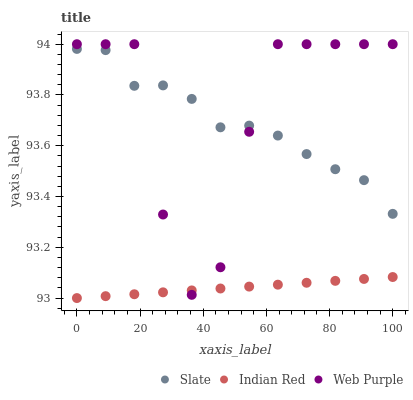Does Indian Red have the minimum area under the curve?
Answer yes or no. Yes. Does Web Purple have the maximum area under the curve?
Answer yes or no. Yes. Does Web Purple have the minimum area under the curve?
Answer yes or no. No. Does Indian Red have the maximum area under the curve?
Answer yes or no. No. Is Indian Red the smoothest?
Answer yes or no. Yes. Is Web Purple the roughest?
Answer yes or no. Yes. Is Web Purple the smoothest?
Answer yes or no. No. Is Indian Red the roughest?
Answer yes or no. No. Does Indian Red have the lowest value?
Answer yes or no. Yes. Does Web Purple have the lowest value?
Answer yes or no. No. Does Web Purple have the highest value?
Answer yes or no. Yes. Does Indian Red have the highest value?
Answer yes or no. No. Is Indian Red less than Slate?
Answer yes or no. Yes. Is Slate greater than Indian Red?
Answer yes or no. Yes. Does Web Purple intersect Indian Red?
Answer yes or no. Yes. Is Web Purple less than Indian Red?
Answer yes or no. No. Is Web Purple greater than Indian Red?
Answer yes or no. No. Does Indian Red intersect Slate?
Answer yes or no. No. 